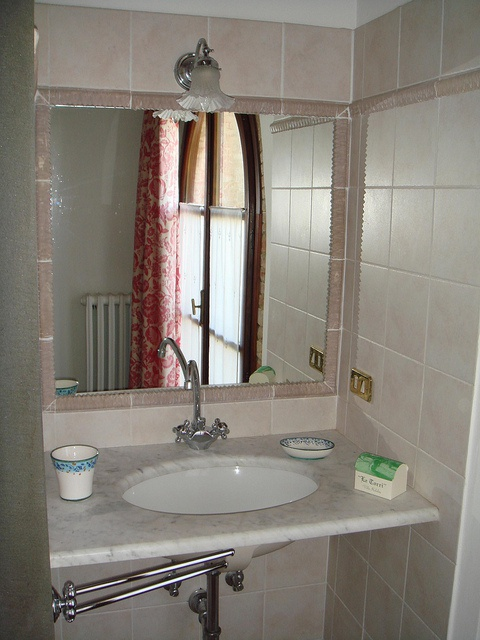Describe the objects in this image and their specific colors. I can see sink in black, darkgray, and gray tones, cup in black, darkgray, gray, and lightgray tones, and bowl in black, darkgray, and gray tones in this image. 